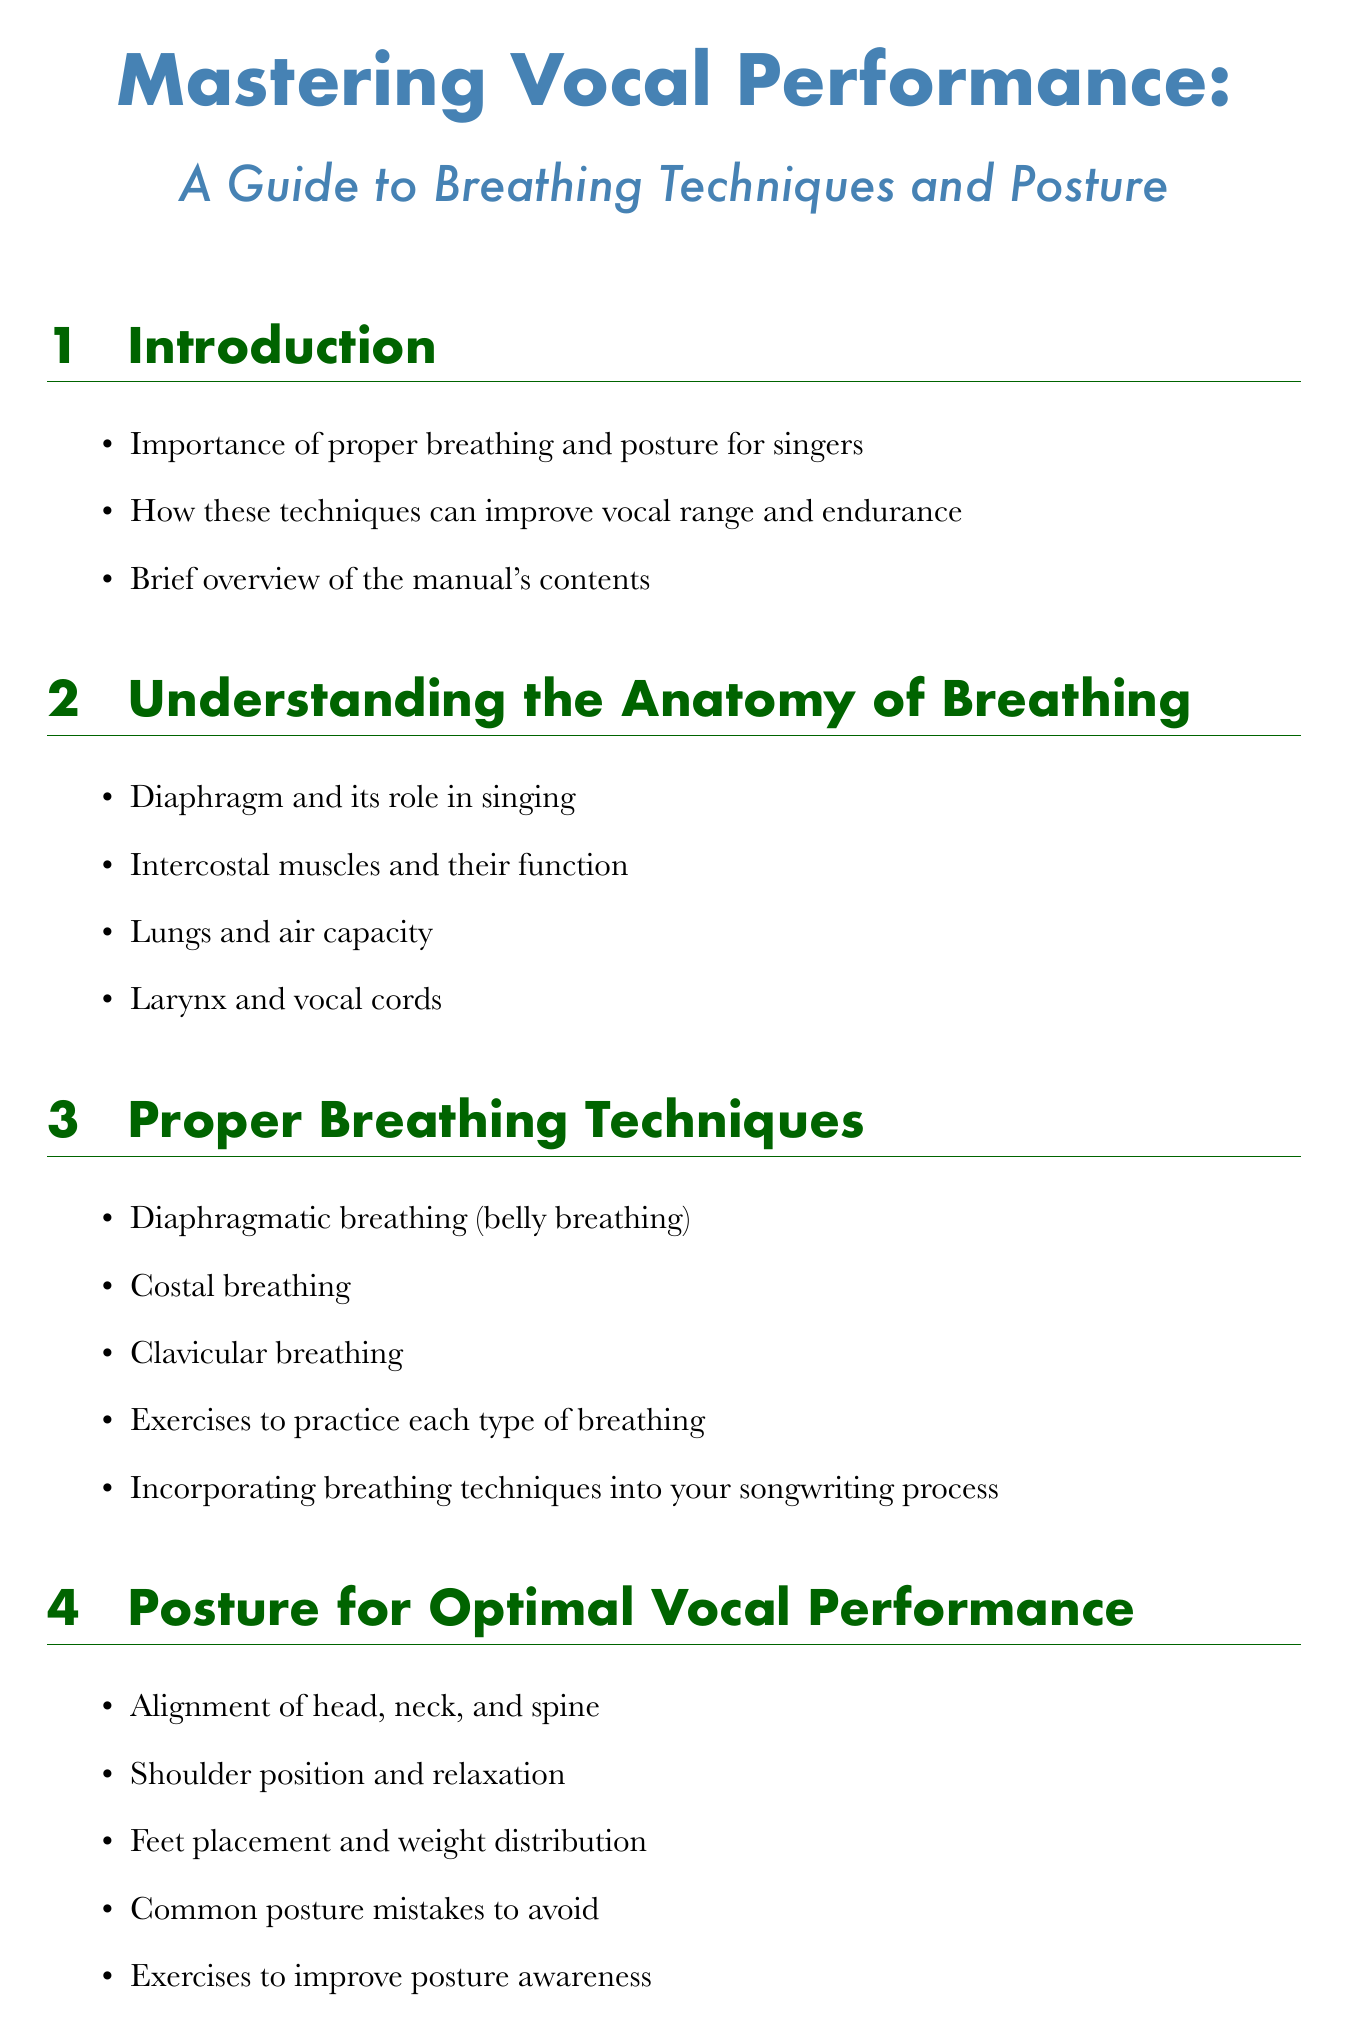What is the title of the manual? The title is explicitly mentioned at the beginning of the document.
Answer: Mastering Vocal Performance: A Guide to Breathing Techniques and Posture Which section discusses the role of the diaphragm? This information can be found in the section that focuses on understanding breathing anatomy.
Answer: Understanding the Anatomy of Breathing What type of breathing is also known as belly breathing? The document lists different types of breathing techniques, one being referred to as belly breathing.
Answer: Diaphragmatic breathing Name one common posture mistake to avoid. This detail is included in the section about posture for optimal vocal performance.
Answer: Common posture mistakes to avoid What exercise is mentioned for breath control? This type of exercise is listed under the breathing exercises section, which aims to help singers.
Answer: Breath control exercises for sustaining long notes Which technique is described as helping with performance anxiety? The techniques for handling anxiety during performances are mentioned in the live performance section.
Answer: Breathing techniques for managing performance anxiety What yoga pose is suggested to improve posture? The manual provides examples of yoga poses mentioned in the posture exercises section.
Answer: Mountain Pose How many recommended books are listed? The resources section mentions two specific books for further learning.
Answer: 2 What advanced technique is discussed for singers? A particular advanced concept related to breathing is outlined in the advanced concepts section.
Answer: Circular breathing technique 